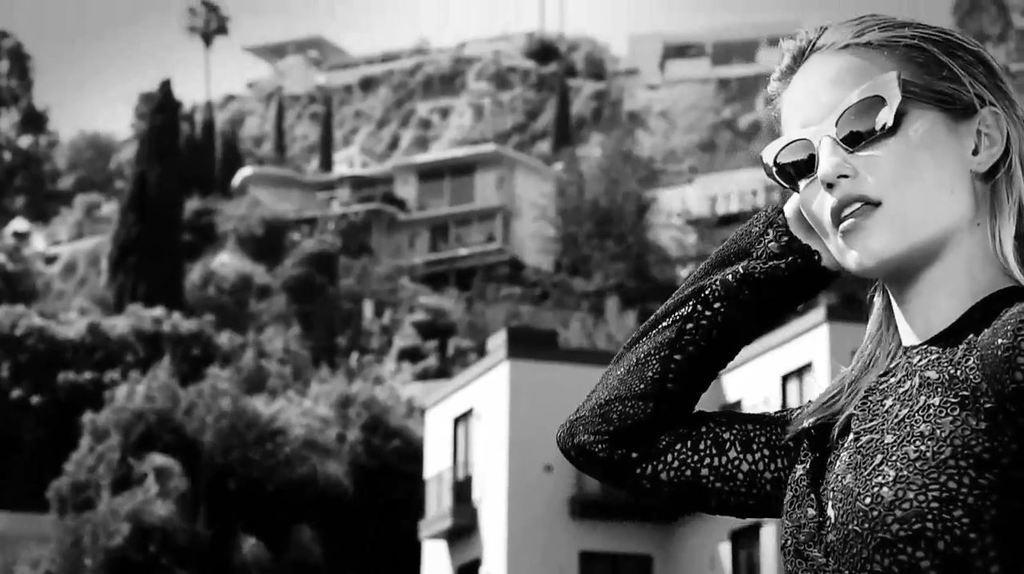Please provide a concise description of this image. It is a black and white picture. On the right side of the image,we can see one woman standing and she is wearing sun glasses. In the background we can see the sky,buildings,trees,windows,poles etc. 